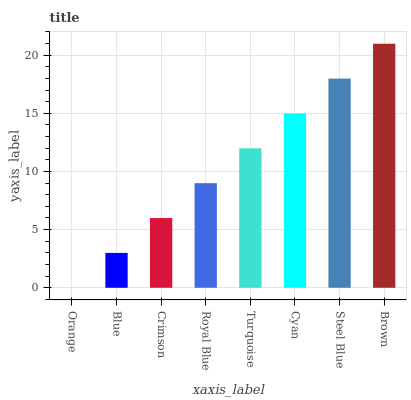Is Orange the minimum?
Answer yes or no. Yes. Is Brown the maximum?
Answer yes or no. Yes. Is Blue the minimum?
Answer yes or no. No. Is Blue the maximum?
Answer yes or no. No. Is Blue greater than Orange?
Answer yes or no. Yes. Is Orange less than Blue?
Answer yes or no. Yes. Is Orange greater than Blue?
Answer yes or no. No. Is Blue less than Orange?
Answer yes or no. No. Is Turquoise the high median?
Answer yes or no. Yes. Is Royal Blue the low median?
Answer yes or no. Yes. Is Brown the high median?
Answer yes or no. No. Is Cyan the low median?
Answer yes or no. No. 